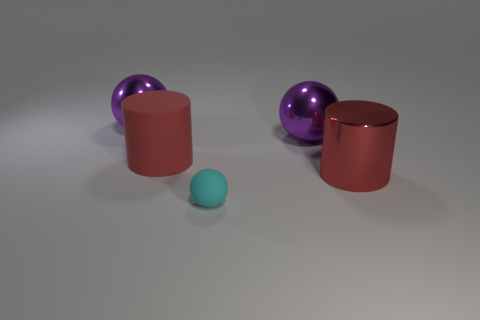Subtract all shiny balls. How many balls are left? 1 Subtract all purple cubes. How many purple balls are left? 2 Subtract 1 spheres. How many spheres are left? 2 Add 2 big yellow cylinders. How many objects exist? 7 Subtract all green balls. Subtract all red cylinders. How many balls are left? 3 Subtract 0 purple cylinders. How many objects are left? 5 Subtract all cylinders. How many objects are left? 3 Subtract all big red metallic balls. Subtract all tiny cyan things. How many objects are left? 4 Add 5 rubber objects. How many rubber objects are left? 7 Add 2 matte cylinders. How many matte cylinders exist? 3 